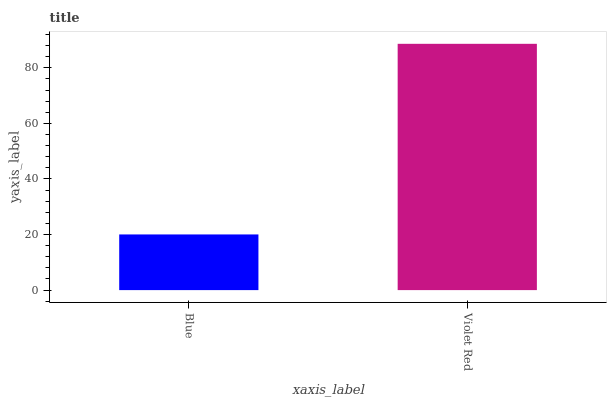Is Blue the minimum?
Answer yes or no. Yes. Is Violet Red the maximum?
Answer yes or no. Yes. Is Violet Red the minimum?
Answer yes or no. No. Is Violet Red greater than Blue?
Answer yes or no. Yes. Is Blue less than Violet Red?
Answer yes or no. Yes. Is Blue greater than Violet Red?
Answer yes or no. No. Is Violet Red less than Blue?
Answer yes or no. No. Is Violet Red the high median?
Answer yes or no. Yes. Is Blue the low median?
Answer yes or no. Yes. Is Blue the high median?
Answer yes or no. No. Is Violet Red the low median?
Answer yes or no. No. 